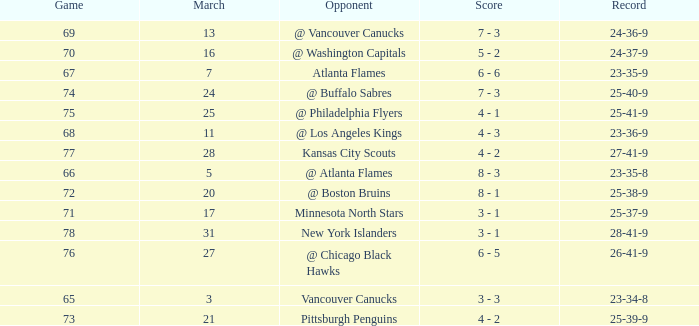What was the score when they had a 25-41-9 record? 4 - 1. 